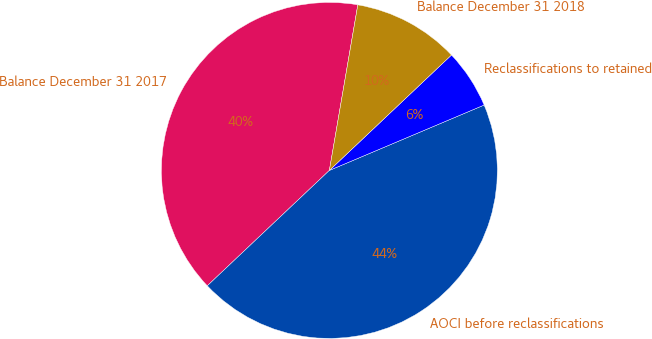Convert chart to OTSL. <chart><loc_0><loc_0><loc_500><loc_500><pie_chart><fcel>Balance December 31 2017<fcel>AOCI before reclassifications<fcel>Reclassifications to retained<fcel>Balance December 31 2018<nl><fcel>39.76%<fcel>44.31%<fcel>5.69%<fcel>10.24%<nl></chart> 